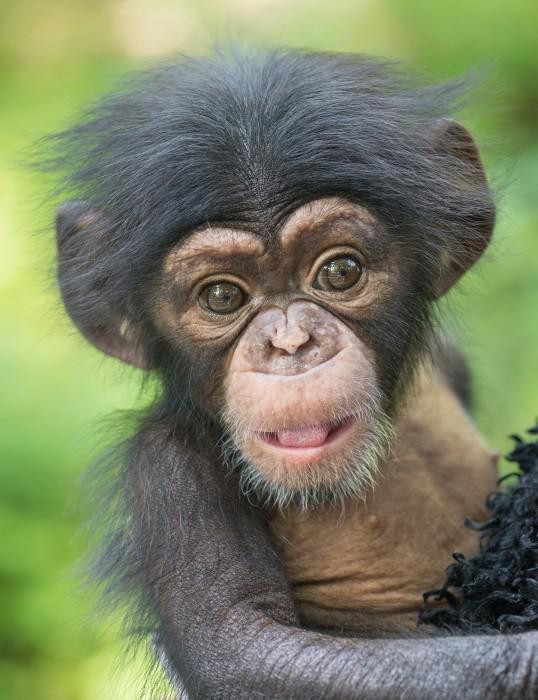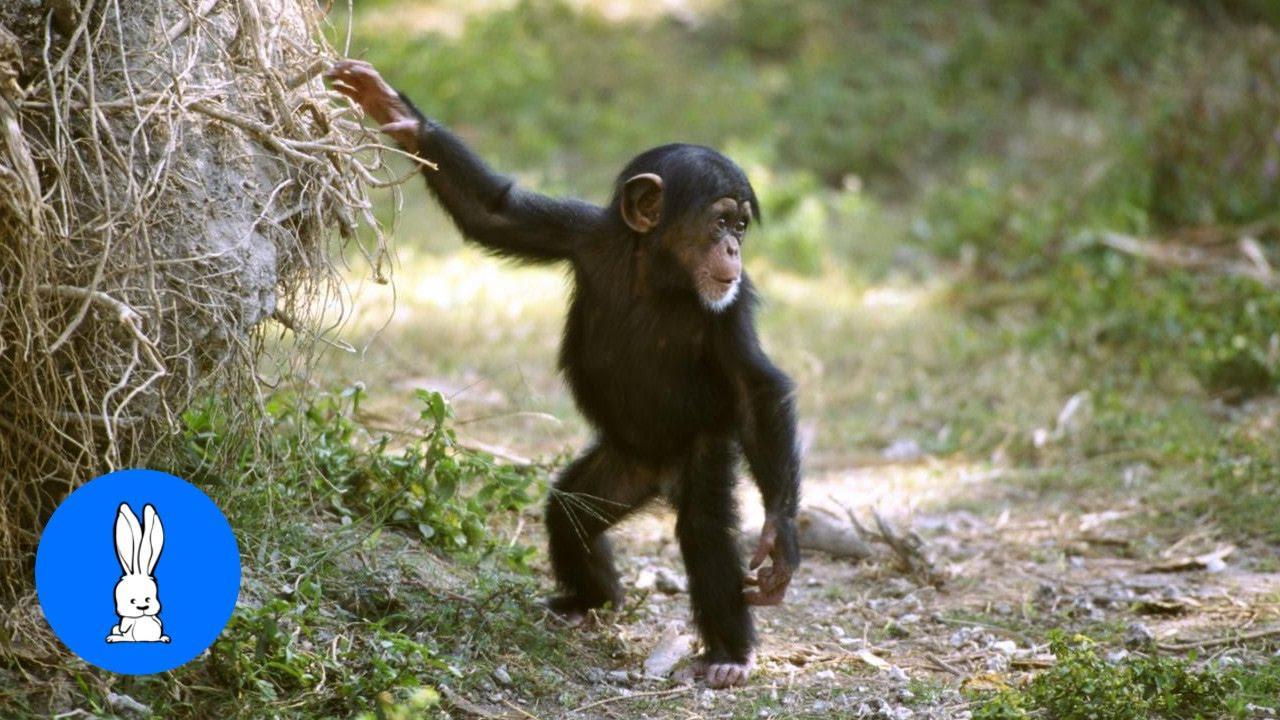The first image is the image on the left, the second image is the image on the right. For the images displayed, is the sentence "A mother and a baby ape is pictured on the right image." factually correct? Answer yes or no. No. 